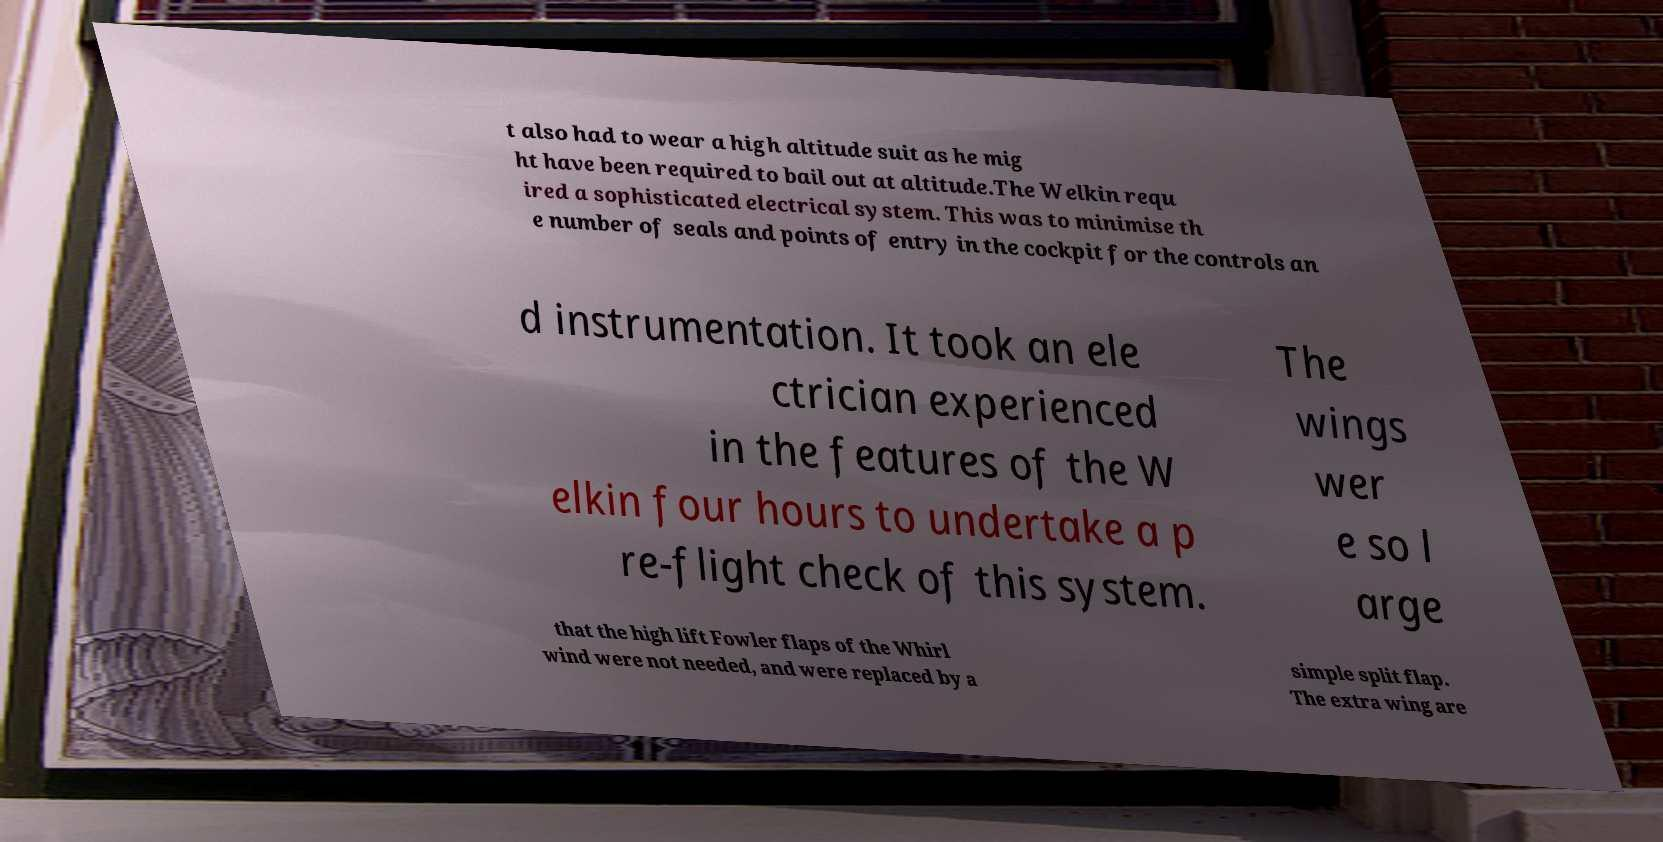I need the written content from this picture converted into text. Can you do that? t also had to wear a high altitude suit as he mig ht have been required to bail out at altitude.The Welkin requ ired a sophisticated electrical system. This was to minimise th e number of seals and points of entry in the cockpit for the controls an d instrumentation. It took an ele ctrician experienced in the features of the W elkin four hours to undertake a p re-flight check of this system. The wings wer e so l arge that the high lift Fowler flaps of the Whirl wind were not needed, and were replaced by a simple split flap. The extra wing are 